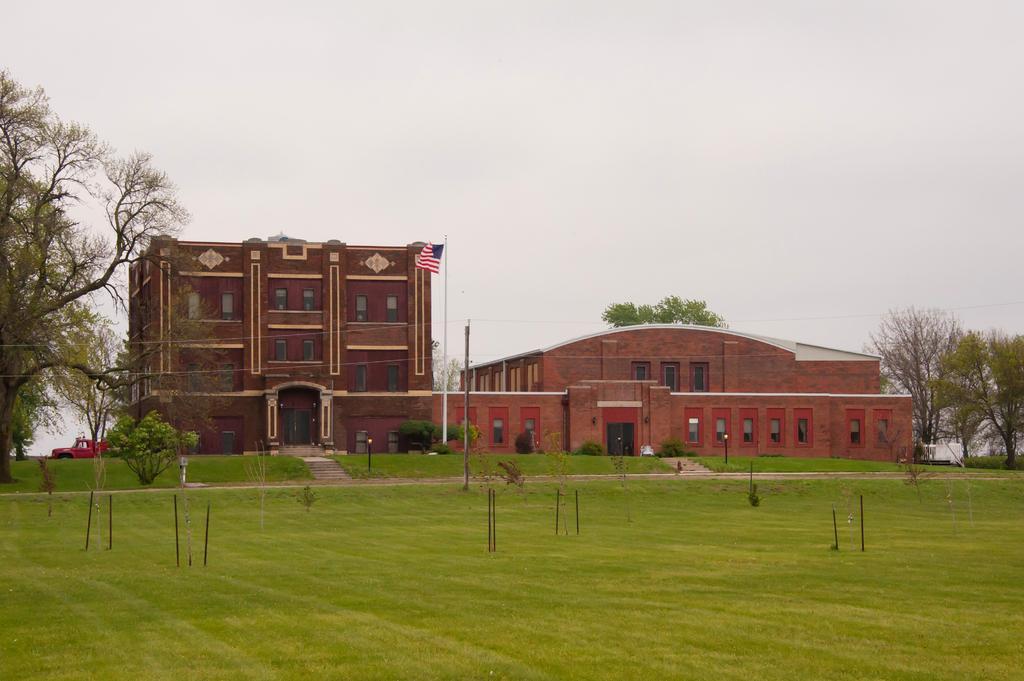In one or two sentences, can you explain what this image depicts? In this picture we can see grass, few trees, poles and buildings, and also we can see a flag and a truck. 